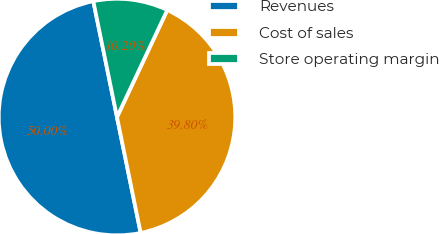<chart> <loc_0><loc_0><loc_500><loc_500><pie_chart><fcel>Revenues<fcel>Cost of sales<fcel>Store operating margin<nl><fcel>50.0%<fcel>39.8%<fcel>10.2%<nl></chart> 